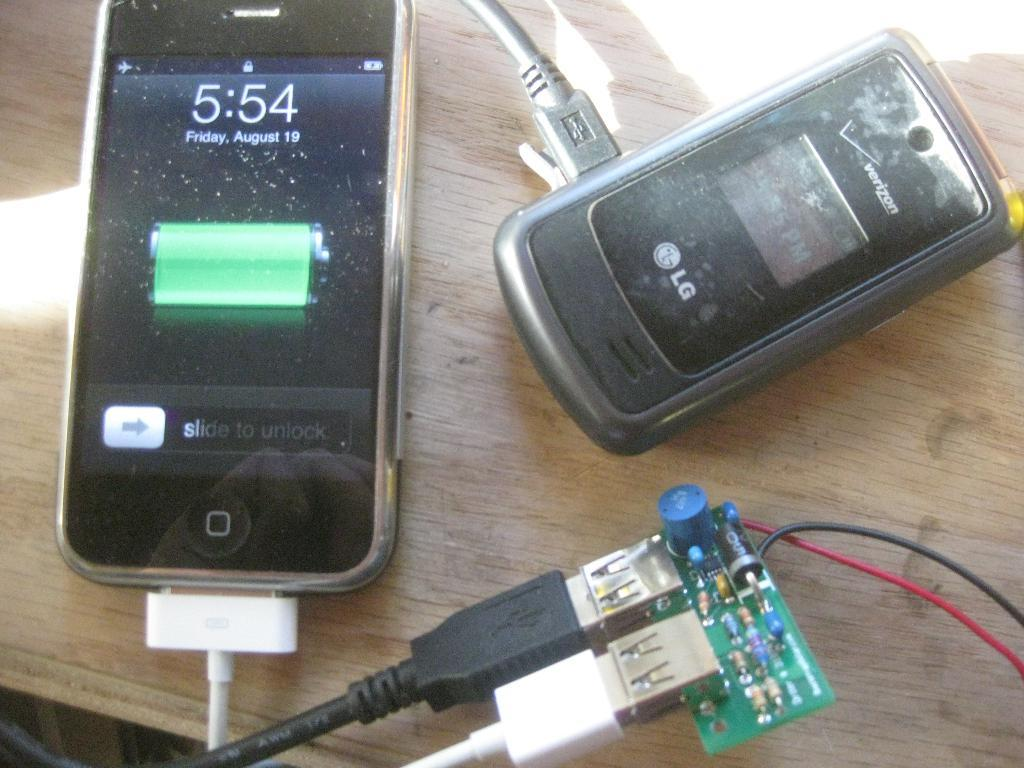<image>
Share a concise interpretation of the image provided. Two cell phones charging and one has 5:54 written on the face. 